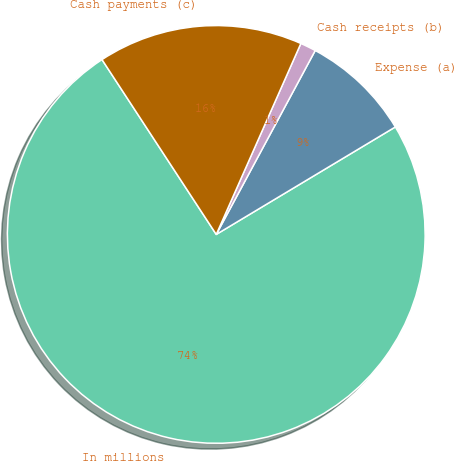<chart> <loc_0><loc_0><loc_500><loc_500><pie_chart><fcel>In millions<fcel>Expense (a)<fcel>Cash receipts (b)<fcel>Cash payments (c)<nl><fcel>74.39%<fcel>8.54%<fcel>1.22%<fcel>15.85%<nl></chart> 